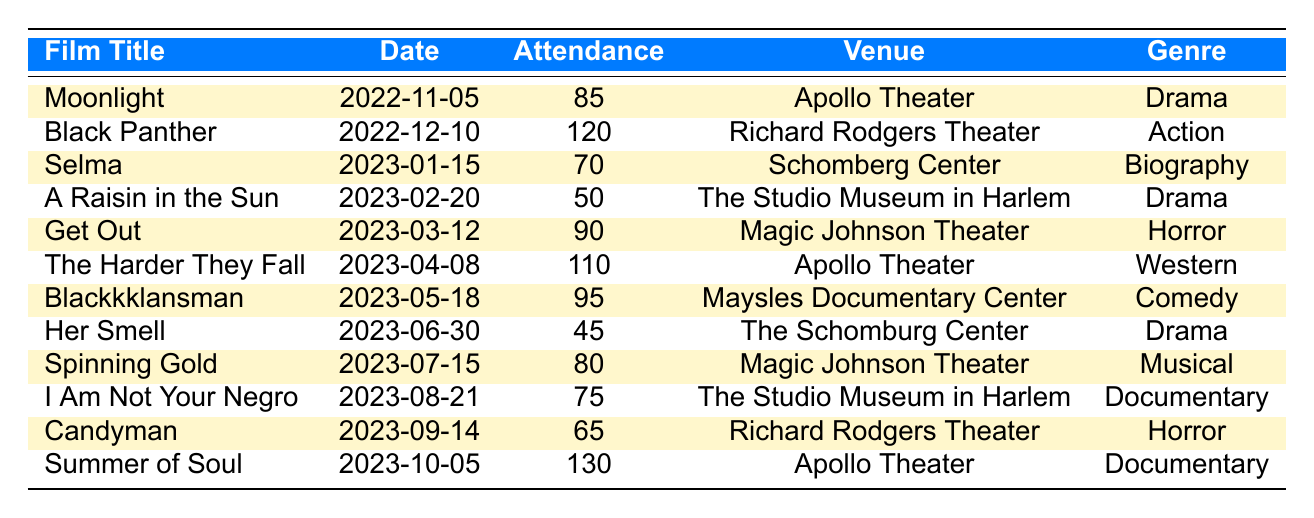What was the highest attendance at a film screening in Harlem over the past year? The data shows that the highest attendance is associated with "Summer of Soul" at the Apollo Theater, which had an attendance of 130.
Answer: 130 How many films had an attendance of over 100? The films with attendance over 100 were "Black Panther" (120), "The Harder They Fall" (110), and "Summer of Soul" (130), making a total of 3 films.
Answer: 3 Is the genre of "Get Out" Drama? "Get Out" is listed as a Horror film in the table. Thus, the answer is false.
Answer: No What is the average attendance for all film screenings held at the Apollo Theater? The Apollo Theater hosted "Moonlight" (85), "The Harder They Fall" (110), and "Summer of Soul" (130). The average attendance is calculated as (85 + 110 + 130) / 3 = 108.33, which rounds to 108 when considering full attendees.
Answer: 108 Did "Her Smell" have higher attendance than "Selma"? "Her Smell" had an attendance of 45, while "Selma" had 70. Therefore, compared to "Selma", "Her Smell" had lower attendance.
Answer: No What venue had the lowest total attendance across all its screenings? Analyzing the venues shows "The Schomburg Center" with "Her Smell" (45) and "I Am Not Your Negro" (75), providing a total of 120. Thus, it has the lowest total attendance compared to other venues.
Answer: The Schomburg Center How many screenings were held in February? During February, one film was screened, "A Raisin in the Sun" on February 20th.
Answer: 1 What was the total attendance for Drama films screened? The Drama films are "Moonlight" (85), "A Raisin in the Sun" (50), and "Her Smell" (45). Their total attendance is (85 + 50 + 45) = 180.
Answer: 180 